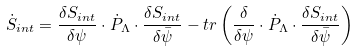<formula> <loc_0><loc_0><loc_500><loc_500>\dot { S } _ { i n t } = \frac { \delta S _ { i n t } } { \delta \psi } \cdot \dot { P } _ { \Lambda } \cdot \frac { \delta S _ { i n t } } { \delta \bar { \psi } } - t r \left ( \frac { \delta } { \delta \psi } \cdot \dot { P } _ { \Lambda } \cdot \frac { \delta S _ { i n t } } { \delta \bar { \psi } } \right )</formula> 